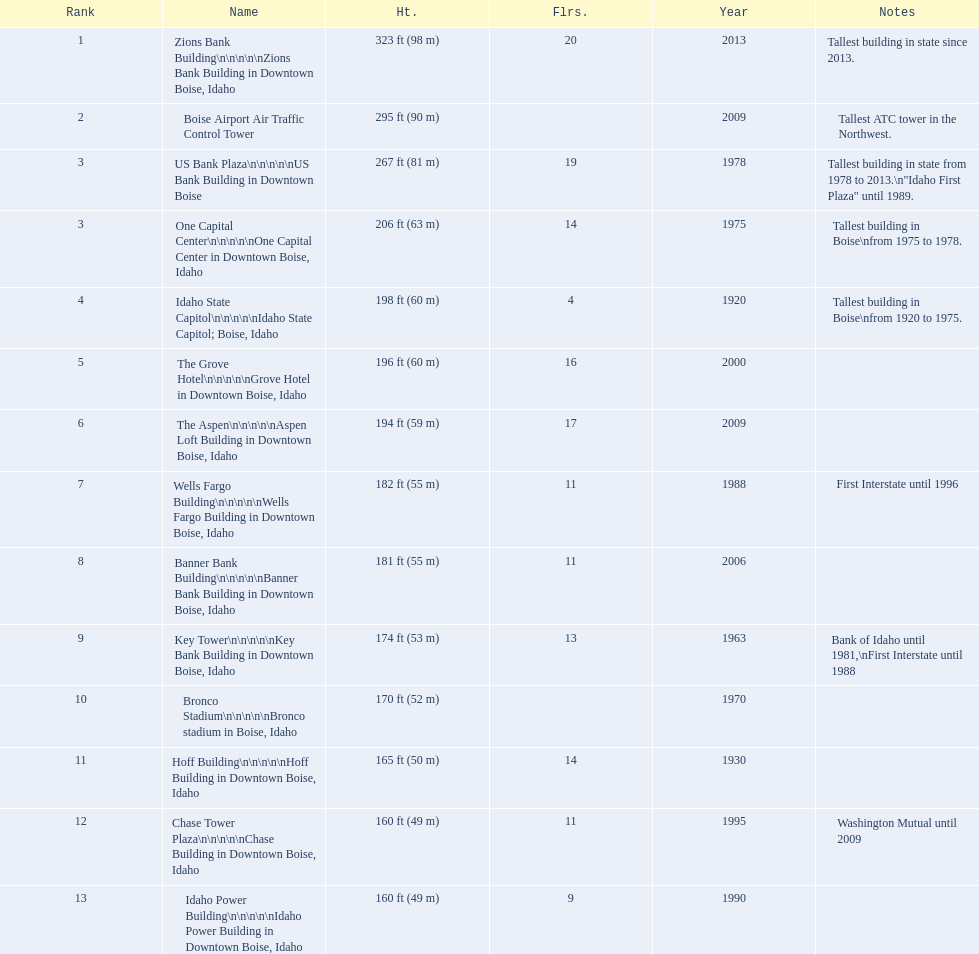Help me parse the entirety of this table. {'header': ['Rank', 'Name', 'Ht.', 'Flrs.', 'Year', 'Notes'], 'rows': [['1', 'Zions Bank Building\\n\\n\\n\\n\\nZions Bank Building in Downtown Boise, Idaho', '323\xa0ft (98\xa0m)', '20', '2013', 'Tallest building in state since 2013.'], ['2', 'Boise Airport Air Traffic Control Tower', '295\xa0ft (90\xa0m)', '', '2009', 'Tallest ATC tower in the Northwest.'], ['3', 'US Bank Plaza\\n\\n\\n\\n\\nUS Bank Building in Downtown Boise', '267\xa0ft (81\xa0m)', '19', '1978', 'Tallest building in state from 1978 to 2013.\\n"Idaho First Plaza" until 1989.'], ['3', 'One Capital Center\\n\\n\\n\\n\\nOne Capital Center in Downtown Boise, Idaho', '206\xa0ft (63\xa0m)', '14', '1975', 'Tallest building in Boise\\nfrom 1975 to 1978.'], ['4', 'Idaho State Capitol\\n\\n\\n\\n\\nIdaho State Capitol; Boise, Idaho', '198\xa0ft (60\xa0m)', '4', '1920', 'Tallest building in Boise\\nfrom 1920 to 1975.'], ['5', 'The Grove Hotel\\n\\n\\n\\n\\nGrove Hotel in Downtown Boise, Idaho', '196\xa0ft (60\xa0m)', '16', '2000', ''], ['6', 'The Aspen\\n\\n\\n\\n\\nAspen Loft Building in Downtown Boise, Idaho', '194\xa0ft (59\xa0m)', '17', '2009', ''], ['7', 'Wells Fargo Building\\n\\n\\n\\n\\nWells Fargo Building in Downtown Boise, Idaho', '182\xa0ft (55\xa0m)', '11', '1988', 'First Interstate until 1996'], ['8', 'Banner Bank Building\\n\\n\\n\\n\\nBanner Bank Building in Downtown Boise, Idaho', '181\xa0ft (55\xa0m)', '11', '2006', ''], ['9', 'Key Tower\\n\\n\\n\\n\\nKey Bank Building in Downtown Boise, Idaho', '174\xa0ft (53\xa0m)', '13', '1963', 'Bank of Idaho until 1981,\\nFirst Interstate until 1988'], ['10', 'Bronco Stadium\\n\\n\\n\\n\\nBronco stadium in Boise, Idaho', '170\xa0ft (52\xa0m)', '', '1970', ''], ['11', 'Hoff Building\\n\\n\\n\\n\\nHoff Building in Downtown Boise, Idaho', '165\xa0ft (50\xa0m)', '14', '1930', ''], ['12', 'Chase Tower Plaza\\n\\n\\n\\n\\nChase Building in Downtown Boise, Idaho', '160\xa0ft (49\xa0m)', '11', '1995', 'Washington Mutual until 2009'], ['13', 'Idaho Power Building\\n\\n\\n\\n\\nIdaho Power Building in Downtown Boise, Idaho', '160\xa0ft (49\xa0m)', '9', '1990', '']]} How tall (in meters) is the tallest building? 98 m. 